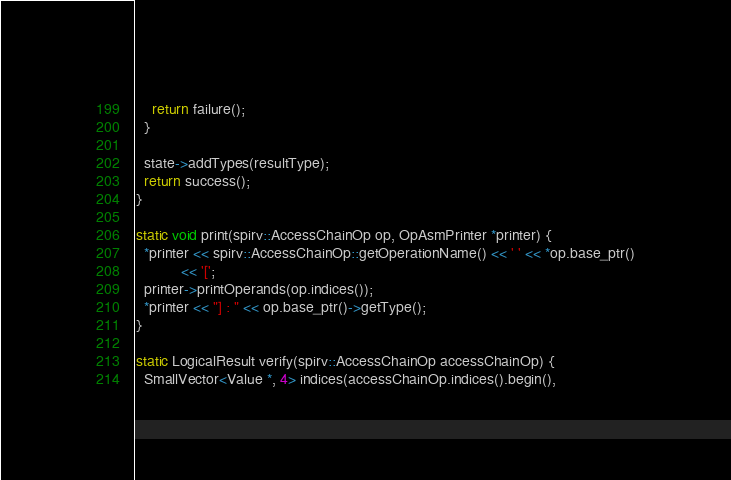Convert code to text. <code><loc_0><loc_0><loc_500><loc_500><_C++_>    return failure();
  }

  state->addTypes(resultType);
  return success();
}

static void print(spirv::AccessChainOp op, OpAsmPrinter *printer) {
  *printer << spirv::AccessChainOp::getOperationName() << ' ' << *op.base_ptr()
           << '[';
  printer->printOperands(op.indices());
  *printer << "] : " << op.base_ptr()->getType();
}

static LogicalResult verify(spirv::AccessChainOp accessChainOp) {
  SmallVector<Value *, 4> indices(accessChainOp.indices().begin(),</code> 